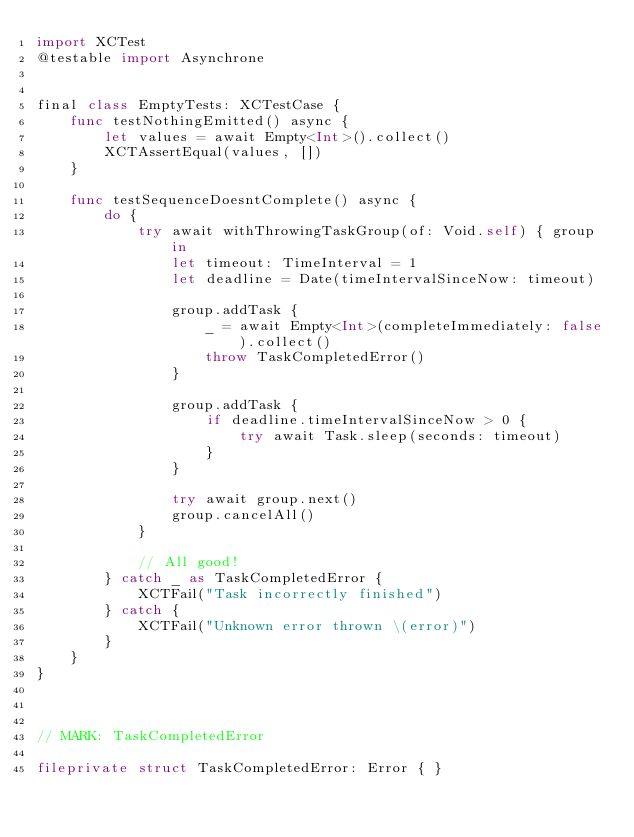Convert code to text. <code><loc_0><loc_0><loc_500><loc_500><_Swift_>import XCTest
@testable import Asynchrone


final class EmptyTests: XCTestCase {
    func testNothingEmitted() async {
        let values = await Empty<Int>().collect()
        XCTAssertEqual(values, [])
    }
    
    func testSequenceDoesntComplete() async {
        do {
            try await withThrowingTaskGroup(of: Void.self) { group in
                let timeout: TimeInterval = 1
                let deadline = Date(timeIntervalSinceNow: timeout)

                group.addTask {
                    _ = await Empty<Int>(completeImmediately: false).collect()
                    throw TaskCompletedError()
                }
                
                group.addTask {
                    if deadline.timeIntervalSinceNow > 0 {
                        try await Task.sleep(seconds: timeout)
                    }
                }
                
                try await group.next()
                group.cancelAll()
            }
            
            // All good!
        } catch _ as TaskCompletedError {
            XCTFail("Task incorrectly finished")
        } catch {
            XCTFail("Unknown error thrown \(error)")
        }
    }
}



// MARK: TaskCompletedError

fileprivate struct TaskCompletedError: Error { }
</code> 